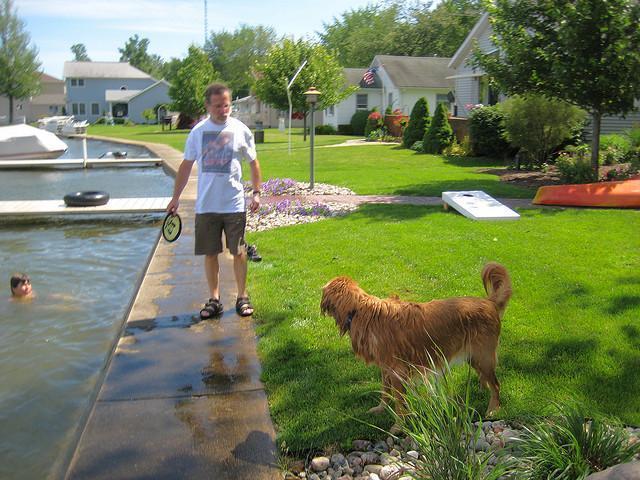How many red bird in this image?
Give a very brief answer. 0. 